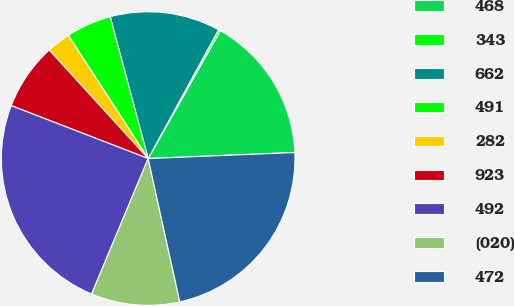Convert chart to OTSL. <chart><loc_0><loc_0><loc_500><loc_500><pie_chart><fcel>468<fcel>343<fcel>662<fcel>491<fcel>282<fcel>923<fcel>492<fcel>(020)<fcel>472<nl><fcel>16.17%<fcel>0.22%<fcel>12.13%<fcel>4.99%<fcel>2.61%<fcel>7.37%<fcel>24.58%<fcel>9.75%<fcel>22.2%<nl></chart> 